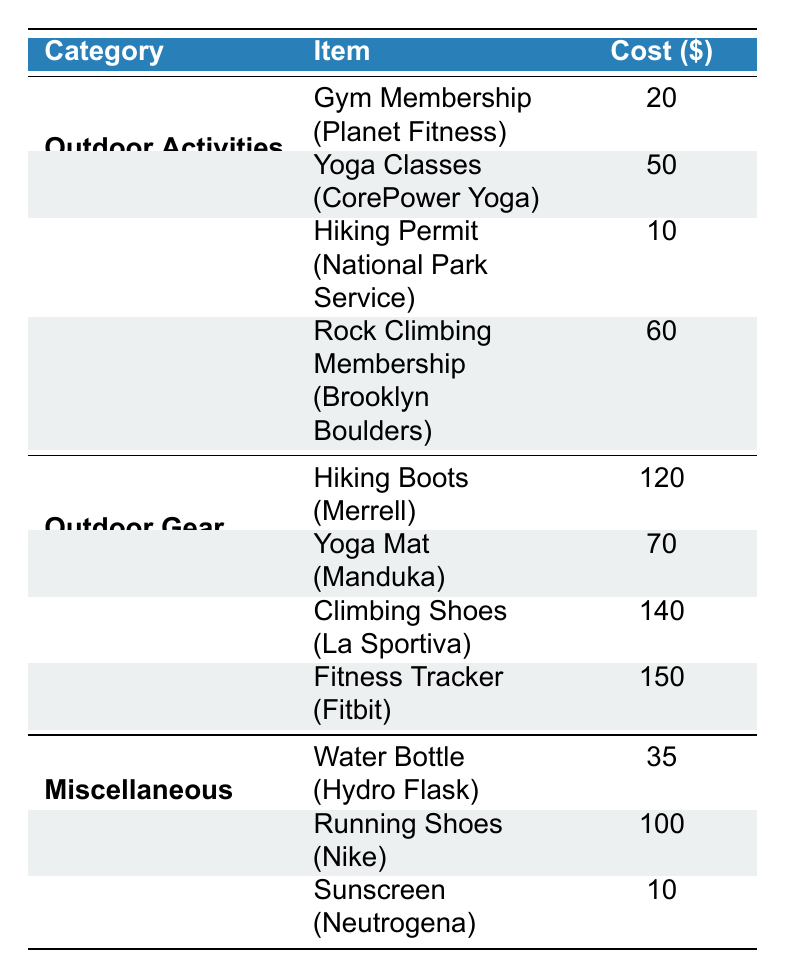What is the total expenditure on Outdoor Activities? To find the total expenditure on Outdoor Activities, we need to sum the costs of each item in that category: Gym Membership ($20) + Yoga Classes ($50) + Hiking Permit ($10) + Rock Climbing Membership ($60). Therefore, the total is 20 + 50 + 10 + 60 = 140.
Answer: 140 How much does a Yoga Mat cost? The table lists the cost of a Yoga Mat under the Outdoor Gear category, which is $70.
Answer: 70 Is the cost of Climbing Shoes greater than that of Hiking Boots? The table shows the cost of Climbing Shoes (La Sportiva) is $140 and that of Hiking Boots (Merrell) is $120. Comparing the two, $140 is greater than $120.
Answer: Yes What is the average cost of items in the Miscellaneous category? To find the average cost, first add the costs of the items in the Miscellaneous category: Water Bottle ($35) + Running Shoes ($100) + Sunscreen ($10). The total cost is 35 + 100 + 10 = 145. There are 3 items, so the average cost is 145 / 3 = 48.33.
Answer: 48.33 Which item has the highest cost, and what is that cost? We need to review the costs of all items listed in the table. The highest cost comes from the Fitness Tracker ($150), which is greater than all other items listed in any category.
Answer: Fitness Tracker, 150 What is the difference between the cost of Rock Climbing Membership and Hiking Permit? The cost of Rock Climbing Membership is $60 and the cost of the Hiking Permit is $10. To find the difference, we subtract the price of the Hiking Permit from that of the Rock Climbing Membership: 60 - 10 = 50.
Answer: 50 How much do the items in the Outdoor Gear category cost in total? The total cost of items in the Outdoor Gear category can be calculated by summing the costs of each item: Hiking Boots ($120) + Yoga Mat ($70) + Climbing Shoes ($140) + Fitness Tracker ($150). The total is 120 + 70 + 140 + 150 = 480.
Answer: 480 Are there any items in the Outdoor Activities category that cost less than $30? The costs of items in the Outdoor Activities category are Gym Membership ($20), Yoga Classes ($50), Hiking Permit ($10), and Rock Climbing Membership ($60). Gym Membership ($20) and Hiking Permit ($10) both cost less than $30.
Answer: Yes What is the median cost of the items listed in the table? First, we list all the costs in order: 10 (Hiking Permit), 20 (Gym Membership), 35 (Water Bottle), 50 (Yoga Classes), 60 (Rock Climbing Membership), 70 (Yoga Mat), 100 (Running Shoes), 120 (Hiking Boots), 140 (Climbing Shoes), 150 (Fitness Tracker). The total number of items is 10. The median is the average of the 5th and 6th items: (60 + 70) / 2 = 65.
Answer: 65 